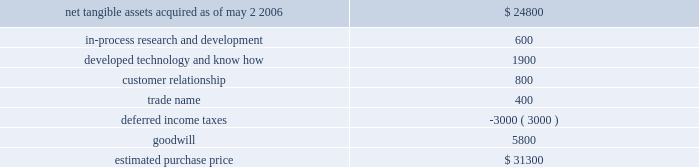Hologic , inc .
Notes to consolidated financial statements ( continued ) ( in thousands , except per share data ) its supply chain and improve manufacturing margins .
The combination of the companies should also facilitate further manufacturing efficiencies and accelerate research and development of new detector products .
Aeg was a privately held group of companies headquartered in warstein , germany , with manufacturing operations in germany , china and the united states .
The aggregate purchase price for aeg was approximately $ 31300 ( subject to adjustment ) consisting of eur $ 24100 in cash and 110 shares of hologic common stock valued at $ 5300 , and approximately $ 1900 for acquisition related fees and expenses .
The company determined the fair value of the shares issued in connection with the acquisition in accordance with eitf issue no .
99-12 , determination of the measurement date for the market price of acquirer securities issued in a purchase business combination .
These 110 shares were subject to contingent put options pursuant to which the holders had the option to resell the shares to the company during a period of one year following the completion of the acquisition if the closing price of the company 2019s stock falls and remains below a threshold price .
The put options were never exercised and expired on may 2 , 2007 .
The acquisition also provided for a one-year earn out of eur 1700 ( approximately $ 2000 usd ) which was payable in cash if aeg calendar year 2006 earnings , as defined , exceeded a pre-determined amount .
Aeg 2019s 2006 earnings did not exceed such pre-determined amounts and no payment was made .
The components and allocation of the purchase price , consists of the following approximate amounts: .
The company implemented a plan to restructure certain of aeg 2019s historical activities .
The company originally recorded a liability of approximately $ 2100 in accordance with eitf issue no .
95-3 , recognition of liabilities in connection with a purchase business combination , related to the termination of certain employees under this plan .
Upon completion of the plan in fiscal 2007 the company reduced this liability by approximately $ 241 with a corresponding reduction in goodwill .
All amounts have been paid as of september 29 , 2007 .
As part of the aeg acquisition the company acquired a minority interest in the equity securities of a private german company .
The company estimated the fair value of these securities to be approximately $ 1400 in its original purchase price allocation .
During the year ended september 29 , 2007 , the company sold these securities for proceeds of approximately $ 2150 .
The difference of approximately $ 750 between the preliminary fair value estimate and proceeds upon sale has been recorded as a reduction of goodwill .
The final purchase price allocations were completed within one year of the acquisition and the adjustments did not have a material impact on the company 2019s financial position or results of operations .
There have been no other material changes to the purchase price allocation as disclosed in the company 2019s form 10-k for the year ended september 30 , 2006 .
As part of the purchase price allocation , all intangible assets that were a part of the acquisition were identified and valued .
It was determined that only customer relationship , trade name , developed technology and know how and in-process research and development had separately identifiable values .
The fair value of these intangible assets was determined through the application of the income approach .
Customer relationship represents aeg 2019s high dependency on a small number of large accounts .
Aeg markets its products through distributors as well as directly to its own customers .
Trade name represents aeg 2019s product names that the company intends to continue to use .
Developed technology and know how represents currently marketable .
What is the fair value of hologic common stock? 
Computations: (5300 / 110)
Answer: 48.18182. 